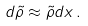<formula> <loc_0><loc_0><loc_500><loc_500>d \tilde { \rho } \approx \tilde { \rho } d x \, .</formula> 